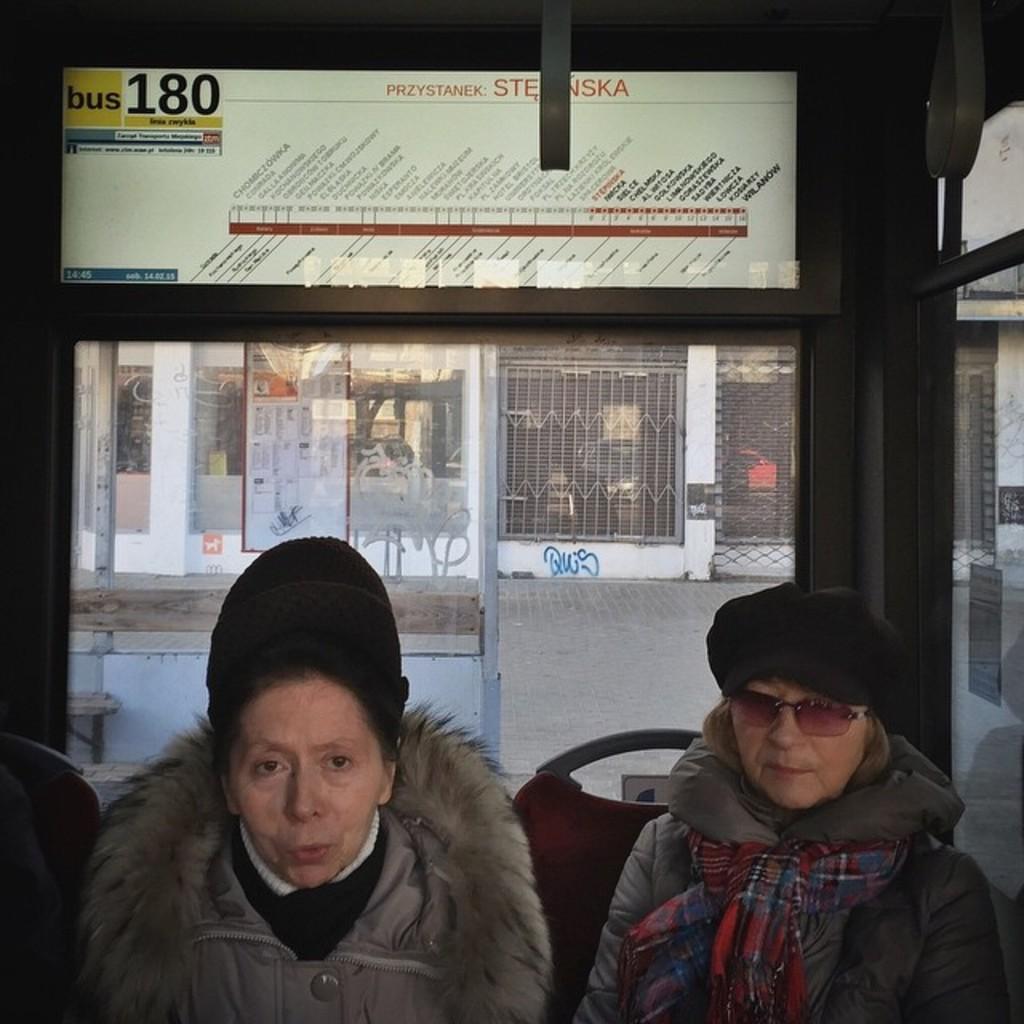Describe this image in one or two sentences. In this image at the bottom there are two people sitting on chairs, and they are wearing jackets and hats. In the background there is a glass door, and through the door we could see a building and some objects. At the top of the image there is a board, on the board there is text and on the left side of the image there is a glass door. On the door there is a poster, and there is a walkway in the center of the image. 